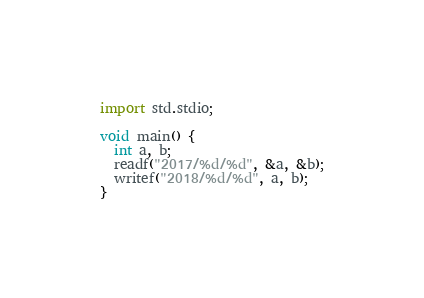Convert code to text. <code><loc_0><loc_0><loc_500><loc_500><_D_>import std.stdio;

void main() {
  int a, b;
  readf("2017/%d/%d", &a, &b);
  writef("2018/%d/%d", a, b);
}</code> 